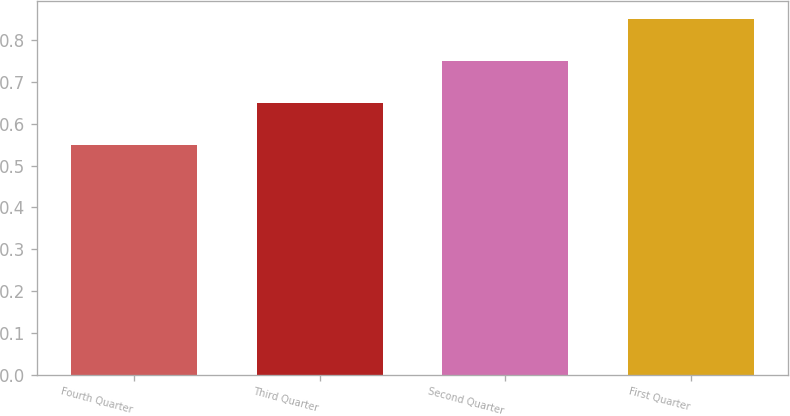Convert chart to OTSL. <chart><loc_0><loc_0><loc_500><loc_500><bar_chart><fcel>Fourth Quarter<fcel>Third Quarter<fcel>Second Quarter<fcel>First Quarter<nl><fcel>0.55<fcel>0.65<fcel>0.75<fcel>0.85<nl></chart> 